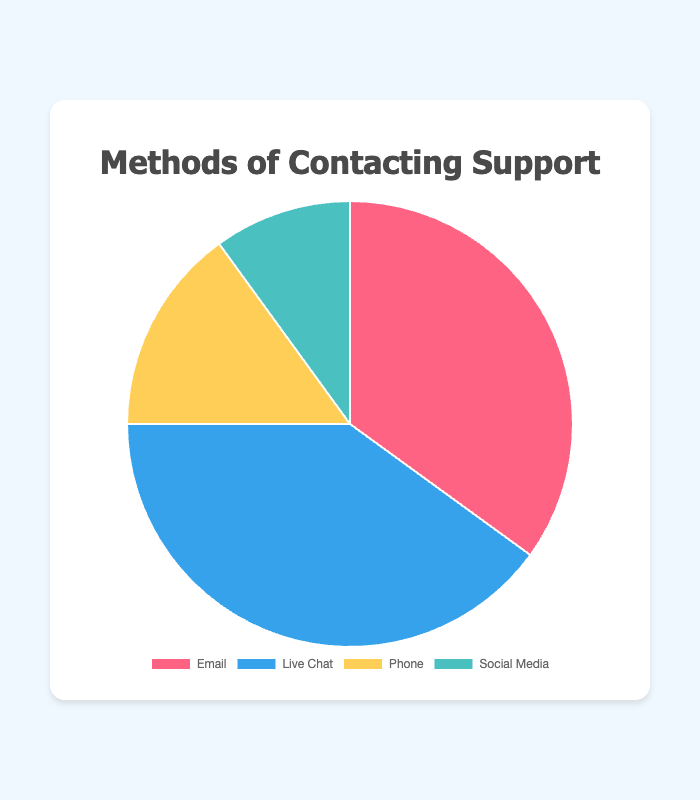How many people prefer contacting support via Email or Phone? To find the total percentage of people who prefer Email or Phone, add the percentage for Email (35%) and Phone (15%). So, 35 + 15 = 50%.
Answer: 50% Which contact method is preferred the most by customers? By looking at the percentages, Live Chat has the highest value at 40%, making it the most preferred method.
Answer: Live Chat How much more popular is Live Chat compared to Social Media? Subtract the percentage of Social Media (10%) from Live Chat (40%) to find the difference. So, 40 - 10 = 30%.
Answer: 30% What's the combined percentage of customers who prefer using Live Chat and Social Media? Add the percentage for Live Chat (40%) and Social Media (10%). So, 40 + 10 = 50%.
Answer: 50% If you were to rank the support methods by popularity, what would the order be? Based on the percentages, rank from highest to lowest: 1) Live Chat (40%), 2) Email (35%), 3) Phone (15%), 4) Social Media (10%).
Answer: Live Chat, Email, Phone, Social Media What is the combined percentage of the least two preferred methods? Add the percentages of Phone (15%) and Social Media (10%). So, 15 + 10 = 25%.
Answer: 25% What percentage of customers prefer methods other than Live Chat? Subtract the percentage of those who prefer Live Chat (40%) from 100%. So, 100 - 40 = 60%.
Answer: 60% Which method has the second highest preference after Live Chat? By looking at the percentages, Email has the second highest value at 35%, after Live Chat.
Answer: Email 